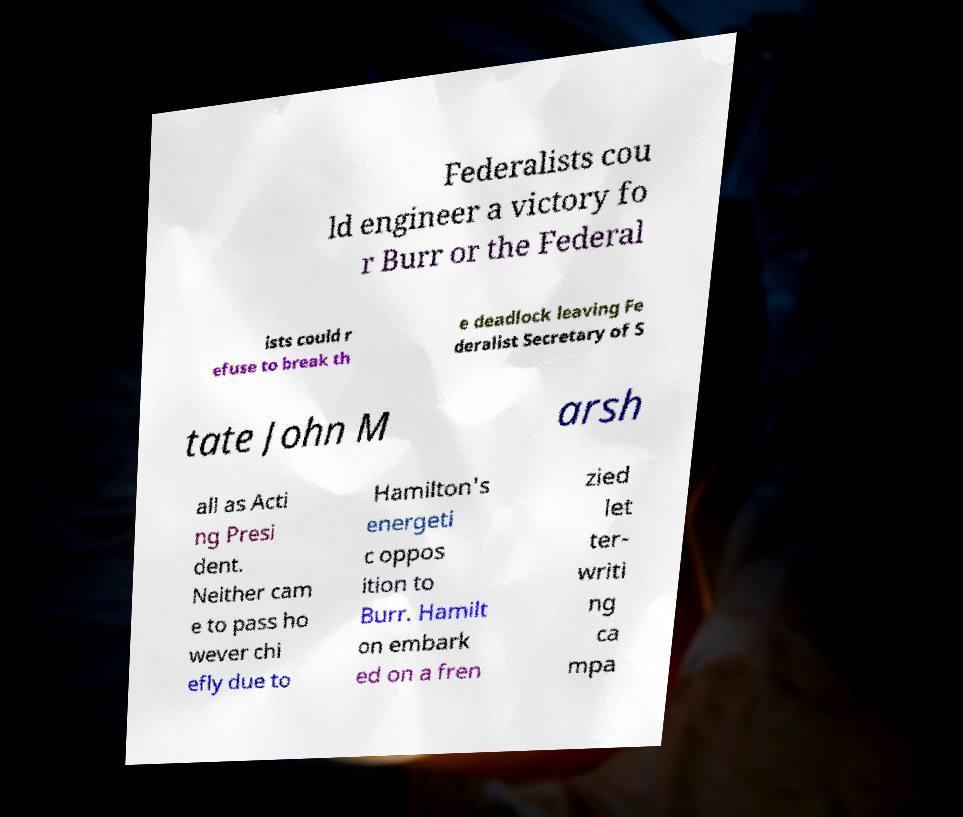Please identify and transcribe the text found in this image. Federalists cou ld engineer a victory fo r Burr or the Federal ists could r efuse to break th e deadlock leaving Fe deralist Secretary of S tate John M arsh all as Acti ng Presi dent. Neither cam e to pass ho wever chi efly due to Hamilton's energeti c oppos ition to Burr. Hamilt on embark ed on a fren zied let ter- writi ng ca mpa 